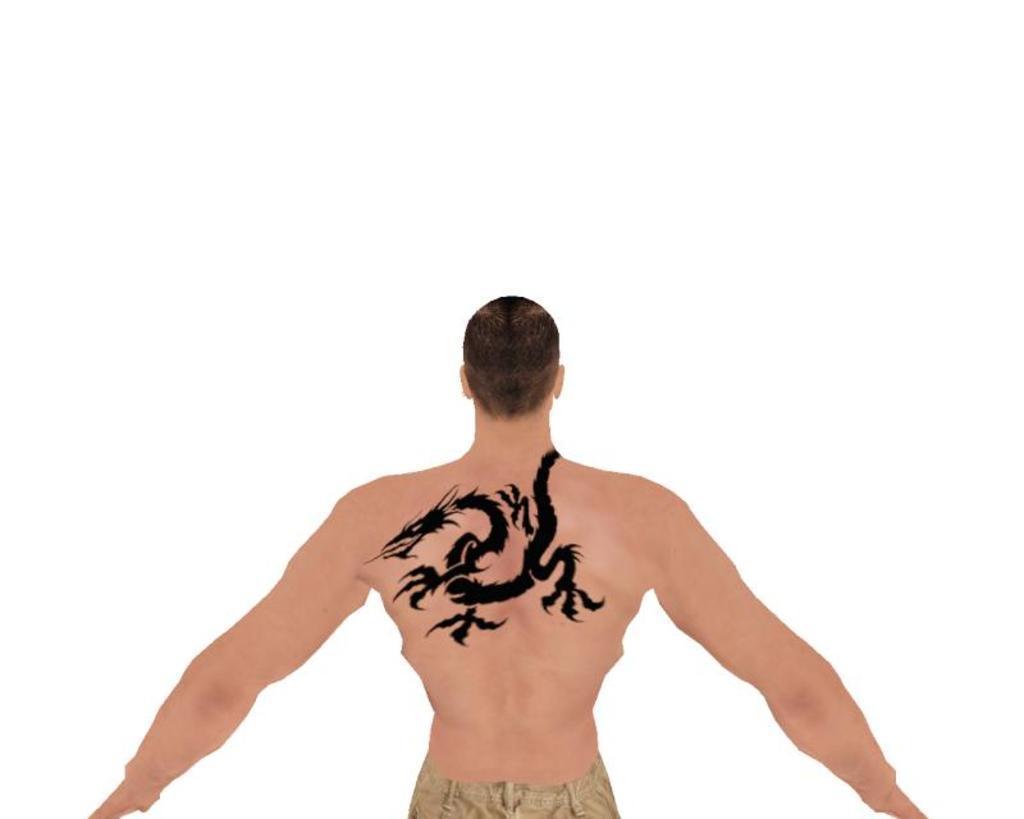Could you give a brief overview of what you see in this image? In this image we can see the depiction of a person with the tattoo. The background of the image is in white color. 